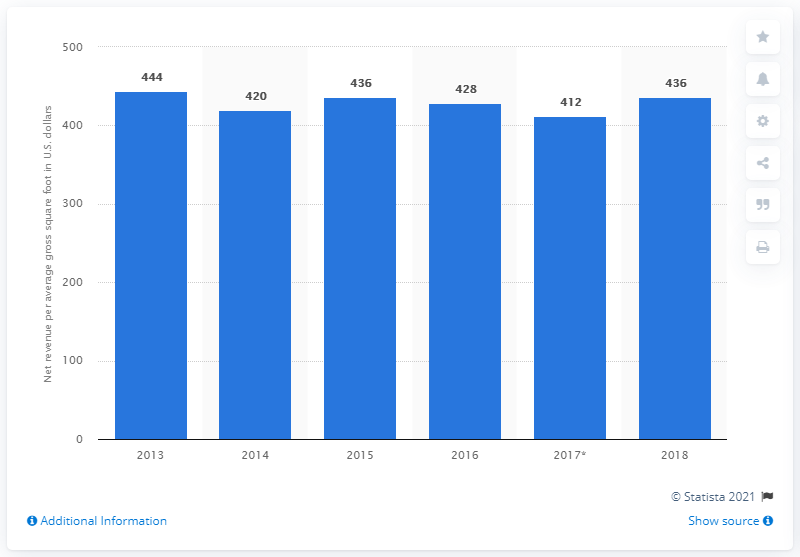Draw attention to some important aspects in this diagram. In 2018, the net revenue per average gross square foot of American Eagle Outfitters was $436. 